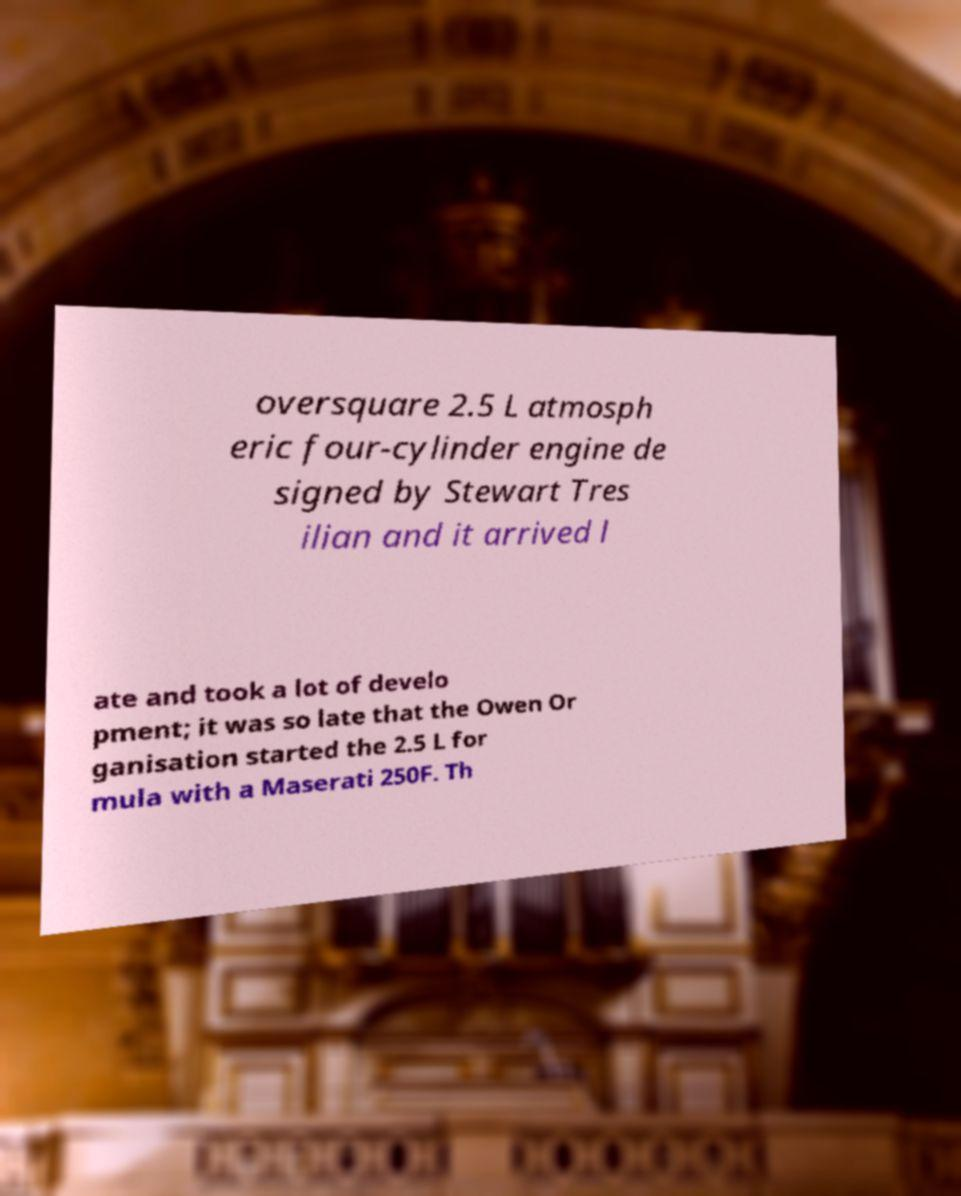Can you accurately transcribe the text from the provided image for me? oversquare 2.5 L atmosph eric four-cylinder engine de signed by Stewart Tres ilian and it arrived l ate and took a lot of develo pment; it was so late that the Owen Or ganisation started the 2.5 L for mula with a Maserati 250F. Th 